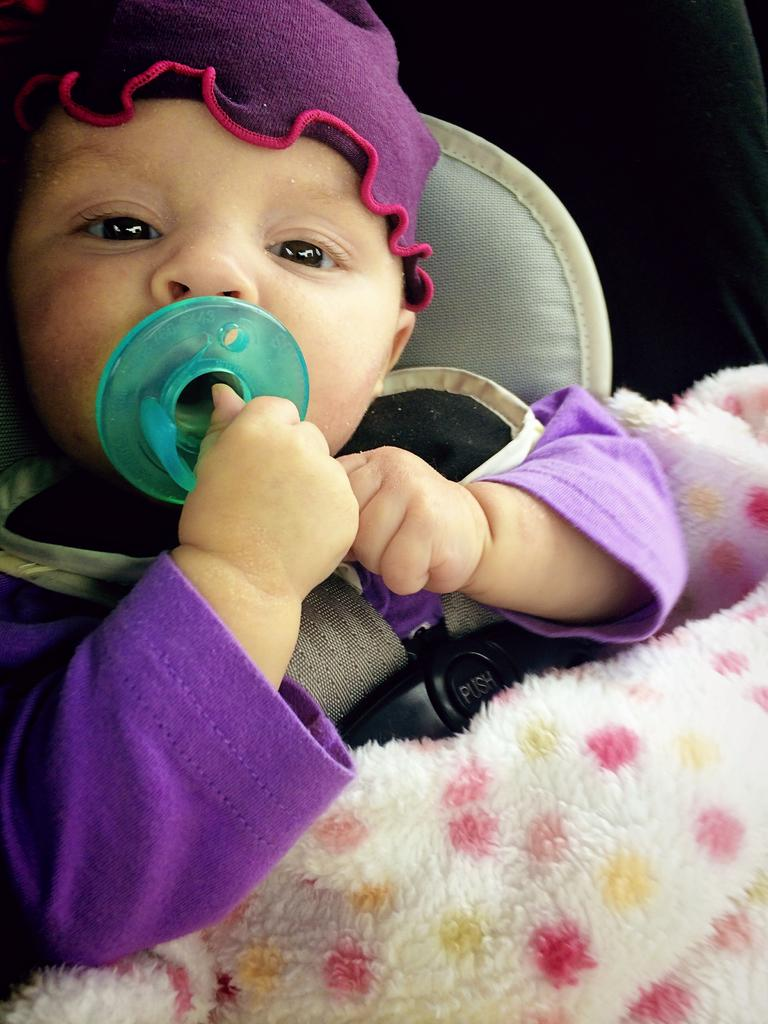What is the main subject of the image? The main subject of the image is a baby. What is the baby holding in their hand? The baby is holding an object in their hand. Where is the baby located in the image? The baby is lying on a bed. Can you describe the setting of the image? The image may have been taken in a room. What type of glue is being used by the baby in the image? There is no glue present in the image, and the baby is not using any glue. 